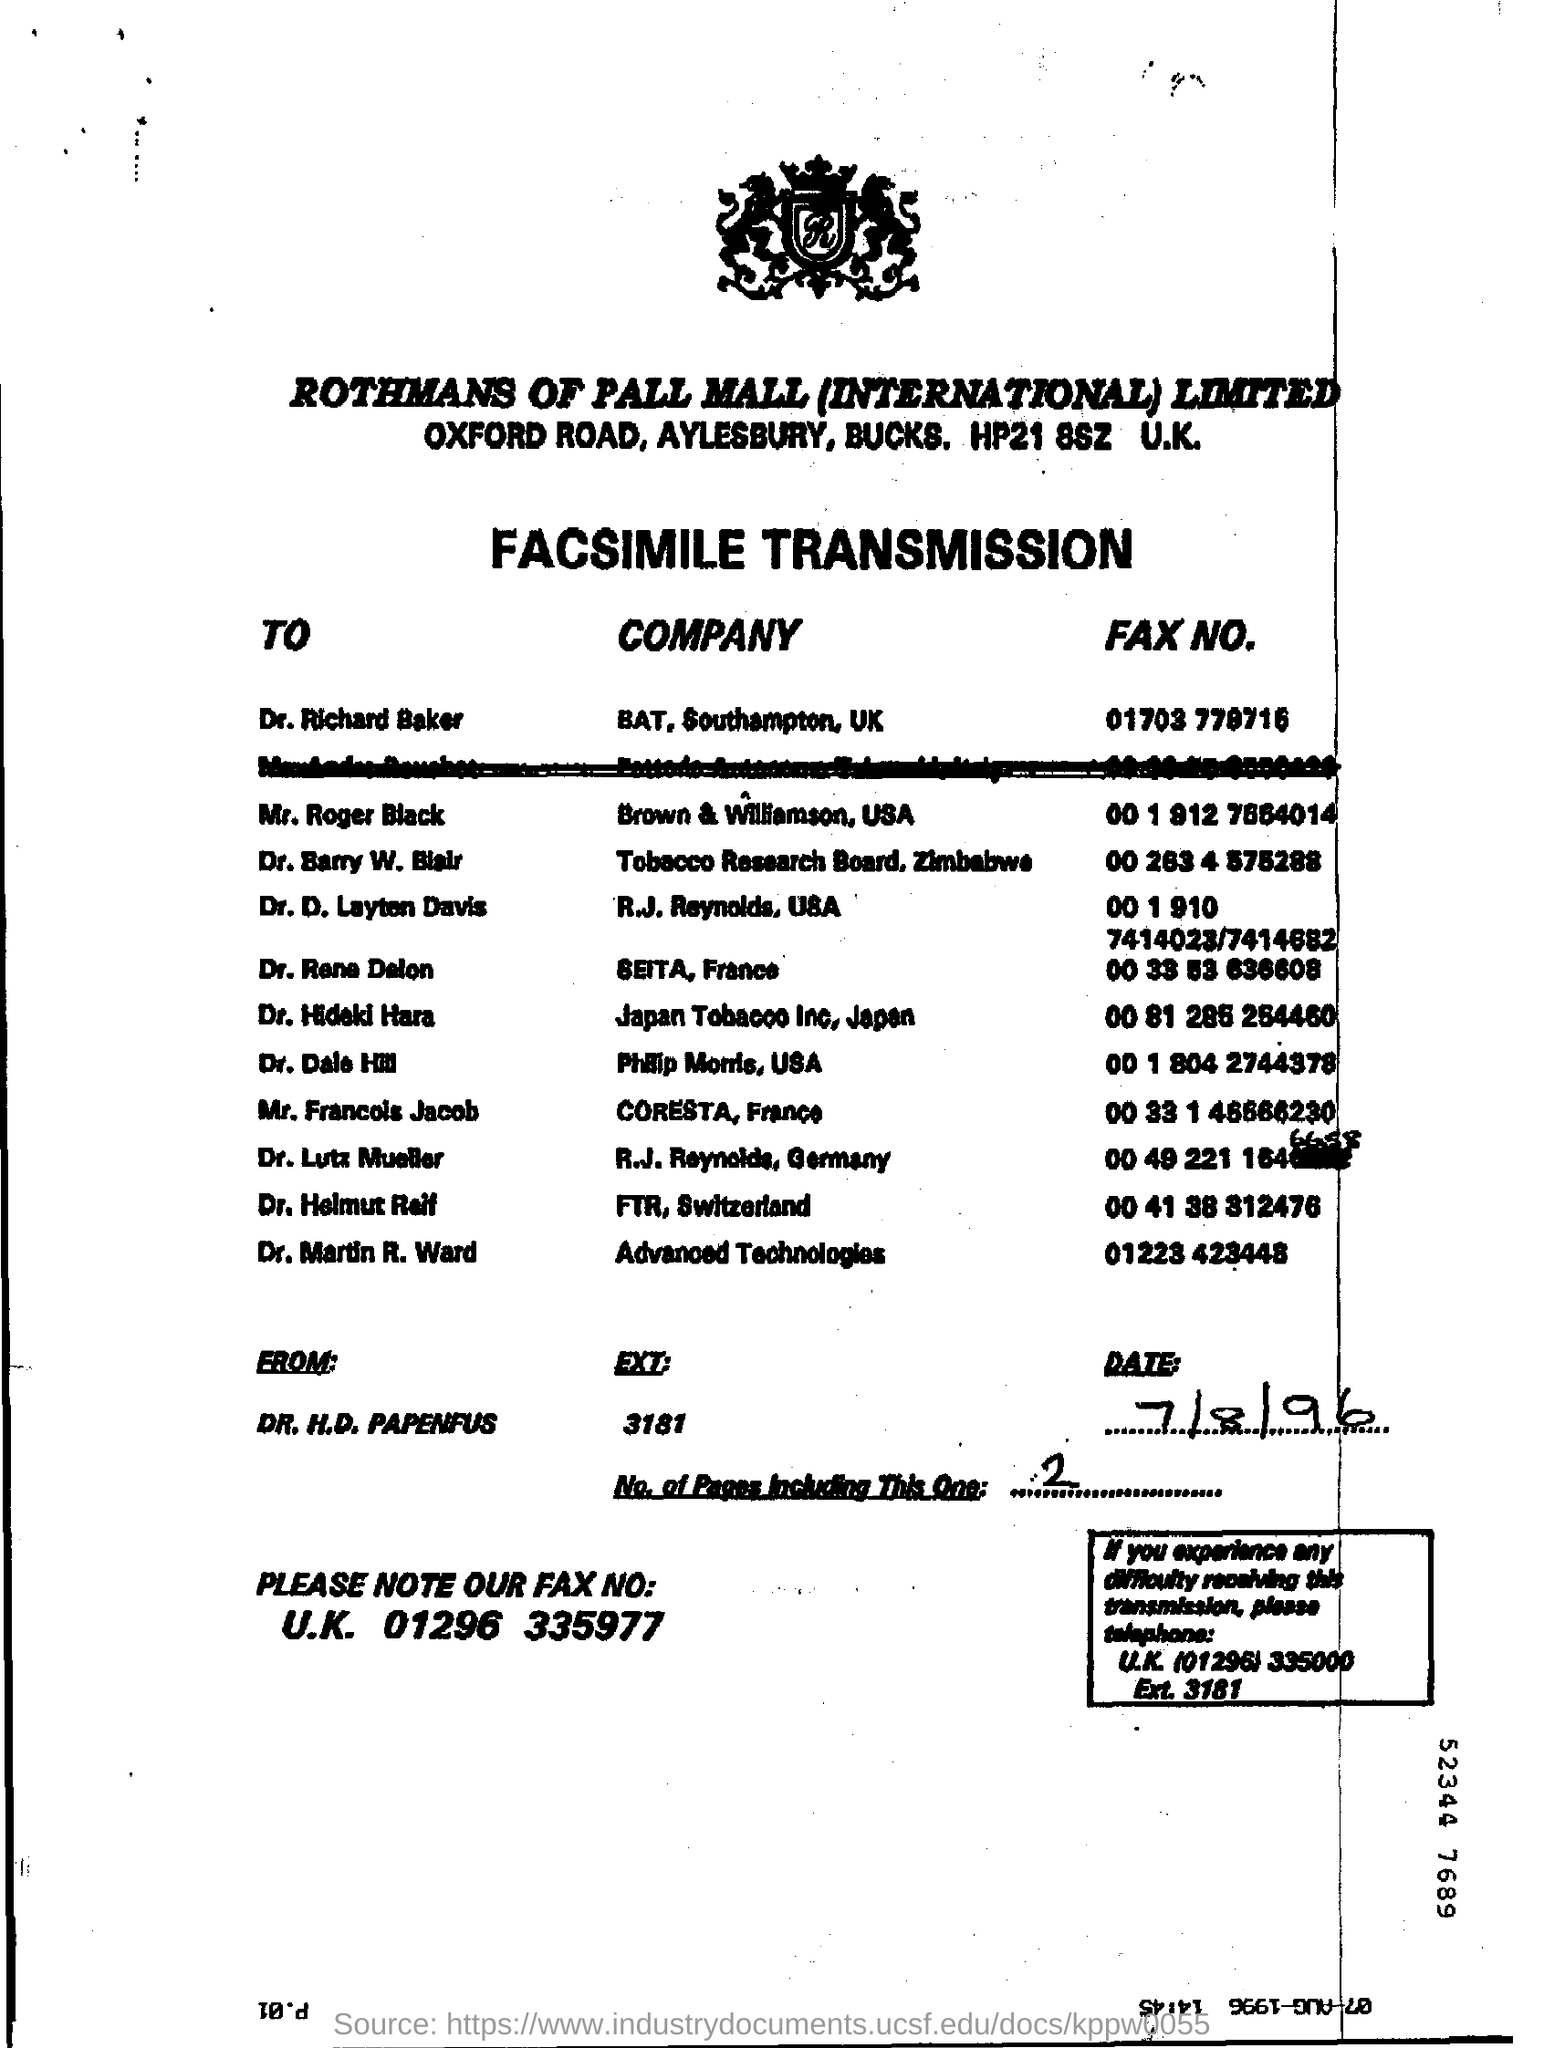Outline some significant characteristics in this image. The EXT mentioned in the fax is 3181... The sender of the FAX is Dr. H.D. Papenfus. Dr. Martin R. Ward is employed by Advanced Technologies Company. I am faxing a document from Rothmans of Pall Mall (International) Limited. 